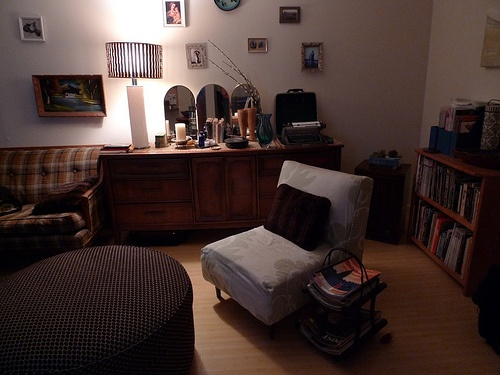Describe the objects in this image and their specific colors. I can see chair in gray and black tones, couch in gray, black, maroon, and brown tones, book in gray, black, maroon, and brown tones, book in gray, black, maroon, and brown tones, and book in maroon, black, brown, and gray tones in this image. 